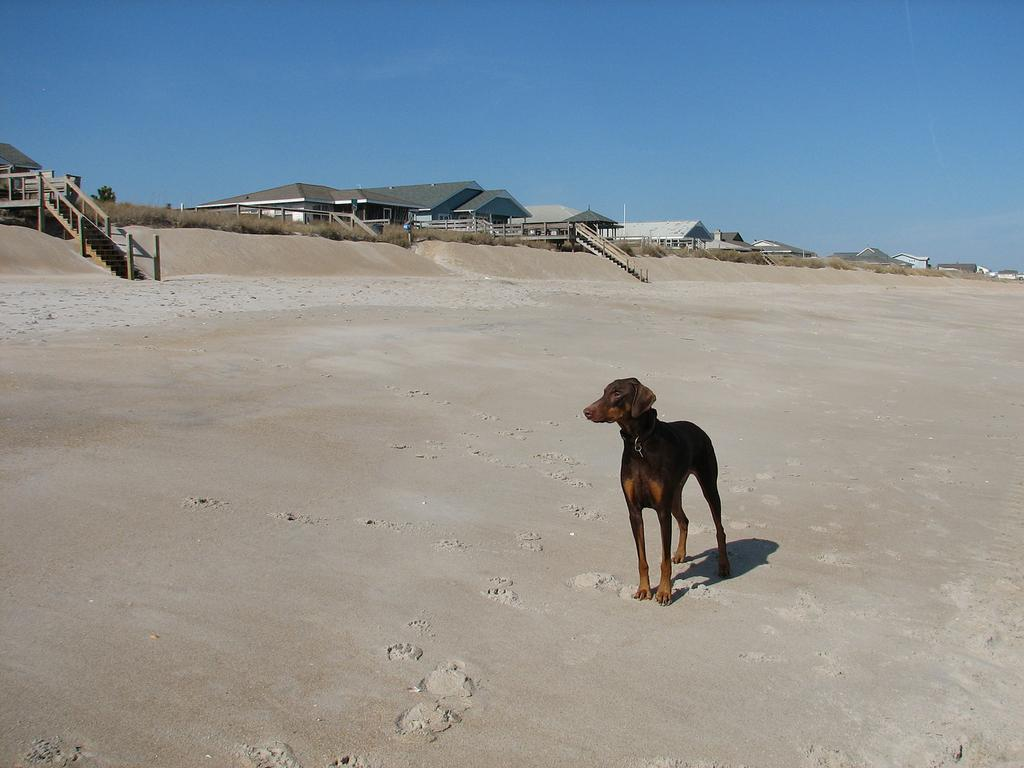What animal can be seen in the image? There is a dog in the image. What is the dog's position in relation to the ground? The dog is standing on the ground. What can be seen in the background of the image? There are houses, a tree, steps, and the sky visible in the background of the image. How many pigs are sitting on the lamp in the image? There are no pigs or lamps present in the image. 